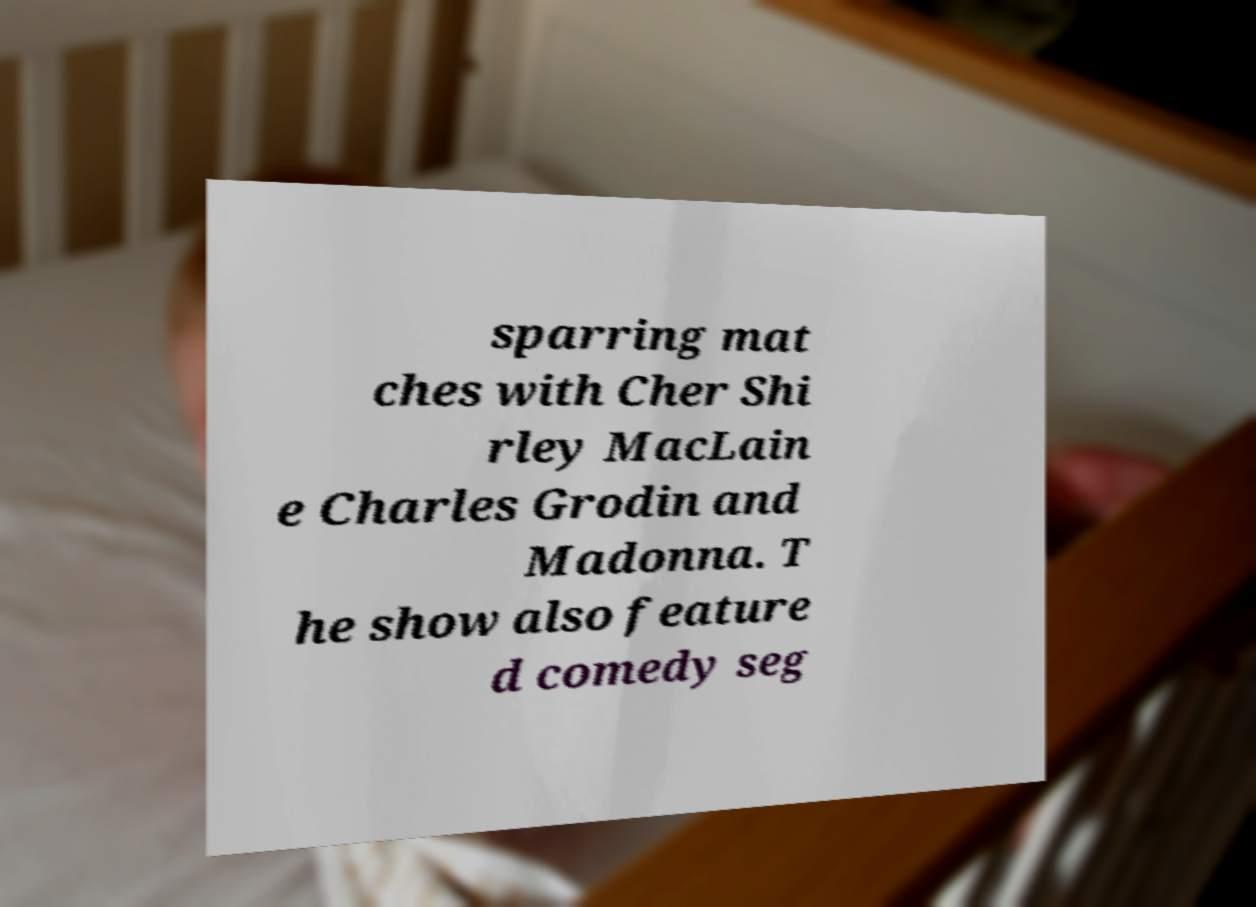For documentation purposes, I need the text within this image transcribed. Could you provide that? sparring mat ches with Cher Shi rley MacLain e Charles Grodin and Madonna. T he show also feature d comedy seg 